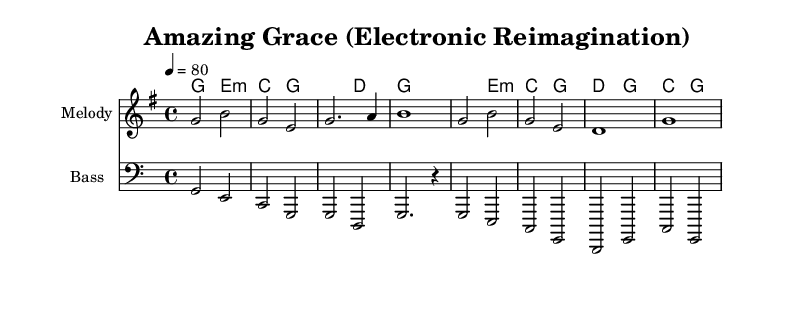What is the key signature of this music? The key signature is G major, which has one sharp (F#). This can be identified from the key indicated at the beginning of the score.
Answer: G major What is the time signature of this music? The time signature is 4/4, which indicates that there are four beats in a measure and the quarter note gets one beat. This is found at the start of the score in the time signature notation.
Answer: 4/4 What is the tempo marking of the music? The tempo marking is 80 beats per minute, as indicated at the beginning of the score with the tempo indication of "4 = 80." This specifies the speed of the piece.
Answer: 80 How many measures does the melody consist of? The melody consists of four measures, as counted from the beginning to the end of the melody section. Each grouping of notes separated by vertical lines represents one measure.
Answer: 4 What is the relationship between the melody and the harmonies in this piece? The melody predominantly features notes that align with the chords of the harmonies. Analyzing both the melody and harmonies reveals that the melody often fits within the notes provided by the underlying chords, reinforcing the piece's harmonic structure. This shows how they complement each other musically.
Answer: Complementary What is the bass clef notation used in this music? The bass clef notation, represented by the clef symbol at the beginning of the bass staff, indicates that the notes on this staff are to be played lower than those in the treble staff. The bass clef assists in identifying pitches for lower instruments or voices.
Answer: Bass clef What electronic element is suggested in the reimagination of this hymn? The electronic elements are implied through the stylistic indication of "Electronic Reimagination" in the title and the potential arrangement, suggesting the use of synthesizers or electronic instruments alongside traditional melodic and harmonic content. The modern interpretation hints at integrating technology in the sound.
Answer: Electronic 